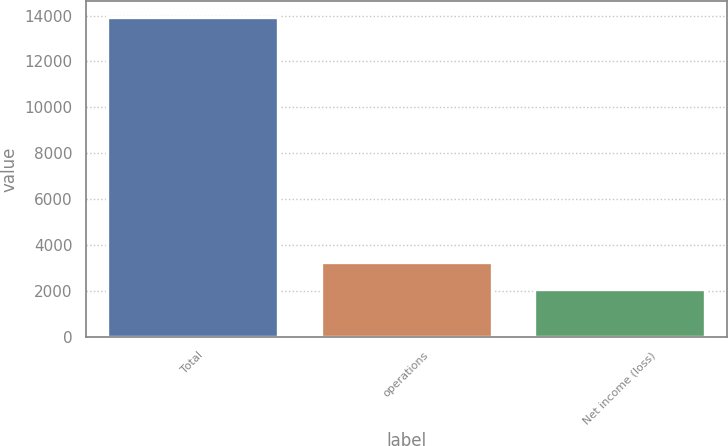Convert chart to OTSL. <chart><loc_0><loc_0><loc_500><loc_500><bar_chart><fcel>Total<fcel>operations<fcel>Net income (loss)<nl><fcel>13951<fcel>3262.6<fcel>2075<nl></chart> 